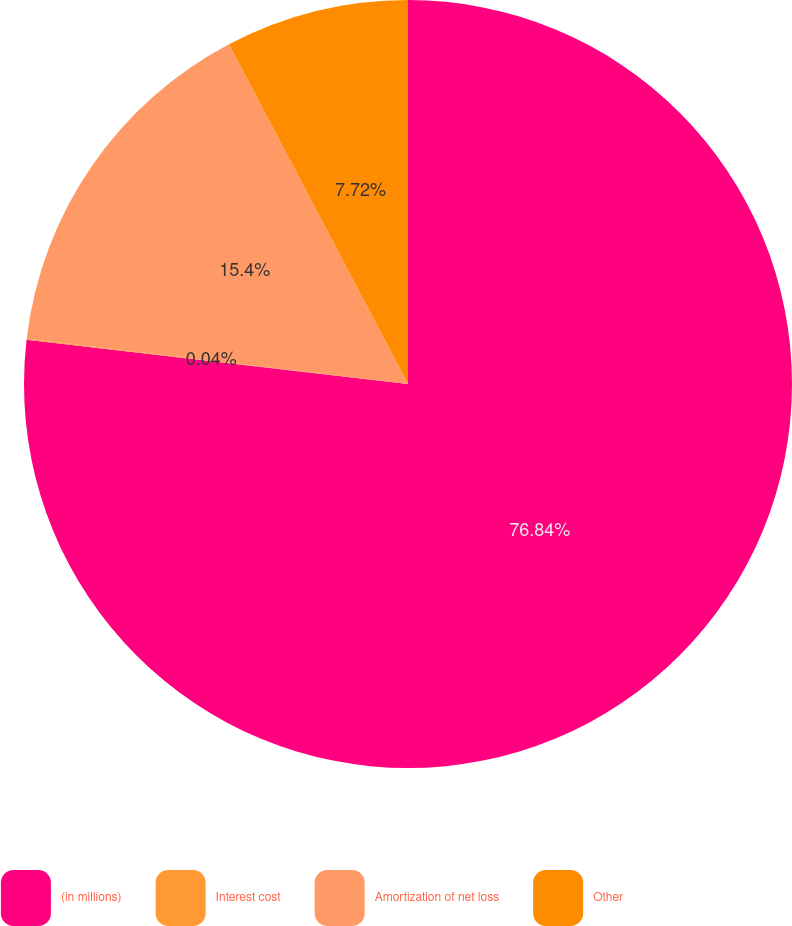<chart> <loc_0><loc_0><loc_500><loc_500><pie_chart><fcel>(in millions)<fcel>Interest cost<fcel>Amortization of net loss<fcel>Other<nl><fcel>76.84%<fcel>0.04%<fcel>15.4%<fcel>7.72%<nl></chart> 